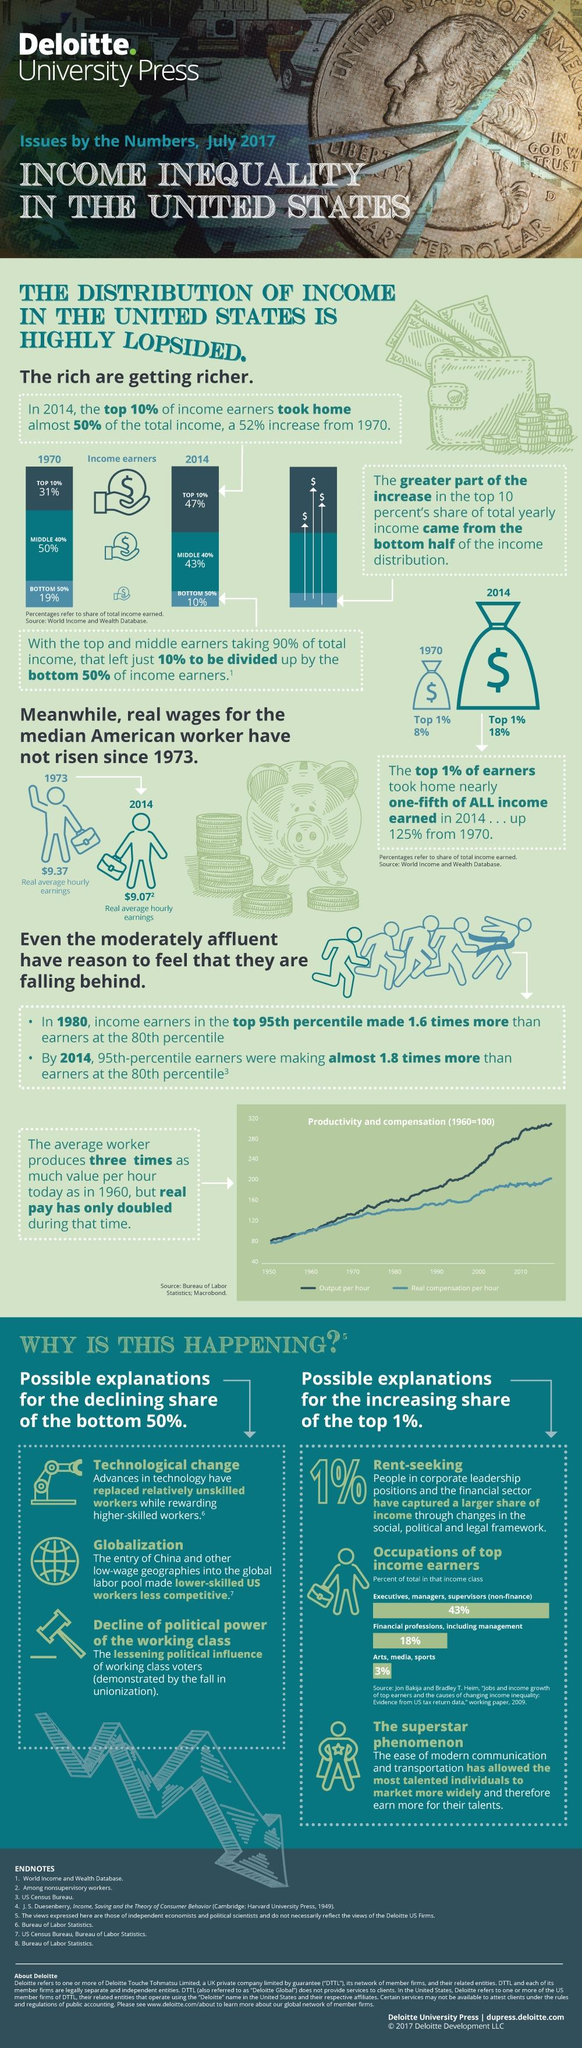Highlight a few significant elements in this photo. The top two income classes accounted for 61% of the total income earned in the country. The 3% of top income earners belong to the category of arts, media, and sports. The entry of China and other low-wage geographies into the global labor pool has made US workers less competitive. In 2014, the share of the top 1% was 18%. From 1970 to 2014, the increase was approximately 52%. 